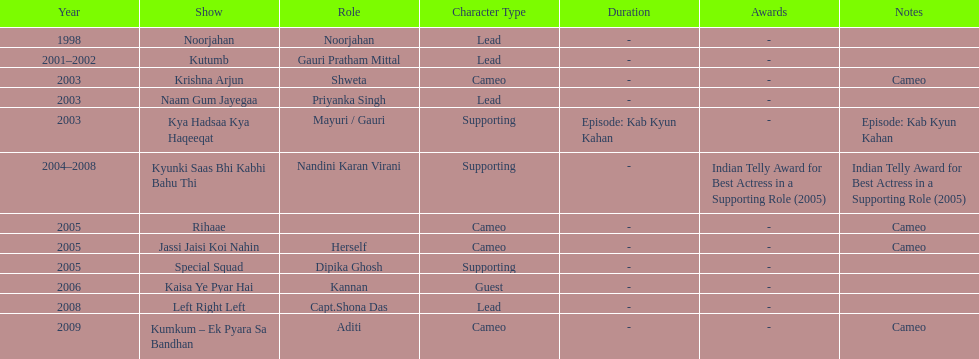How many shows were there in 2005? 3. 